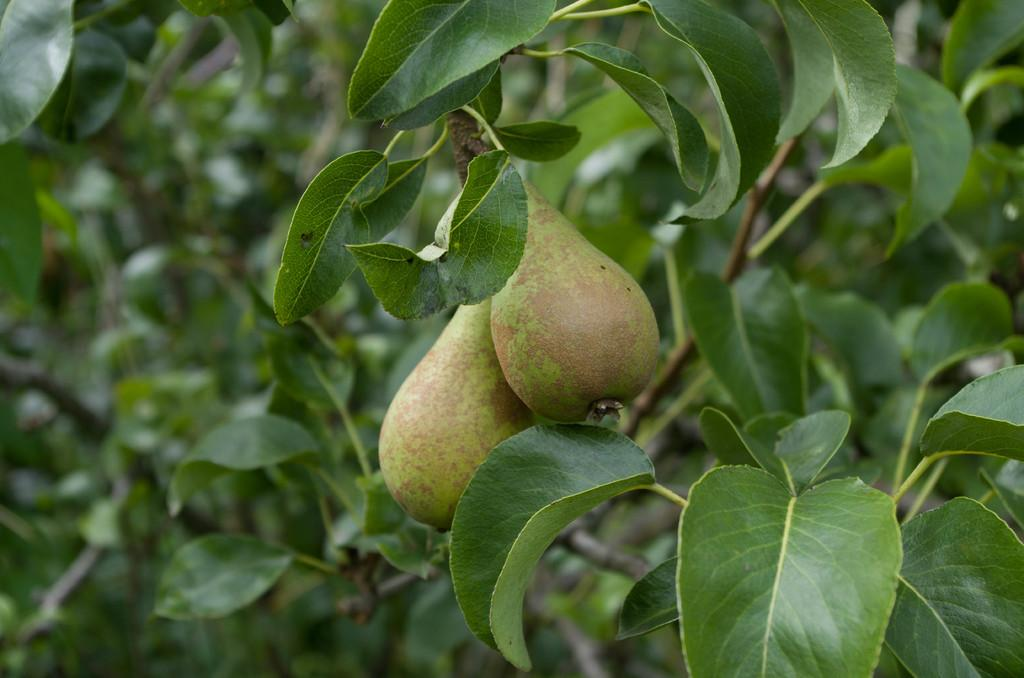What type of plant can be seen in the image? There is a tree in the image. What can be found on the tree? There are two green fruits on a stem. What color are the leaves on the tree? The leaves on the tree are green. What type of knee can be seen on the tree in the image? There is no knee present on the tree in the image; it is a plant, not a living creature. 